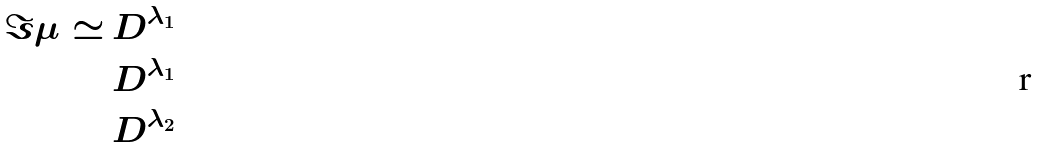Convert formula to latex. <formula><loc_0><loc_0><loc_500><loc_500>\Im \mu \simeq \, & D ^ { \lambda _ { 1 } } \\ & D ^ { \lambda _ { 1 } } \\ & D ^ { \lambda _ { 2 } }</formula> 